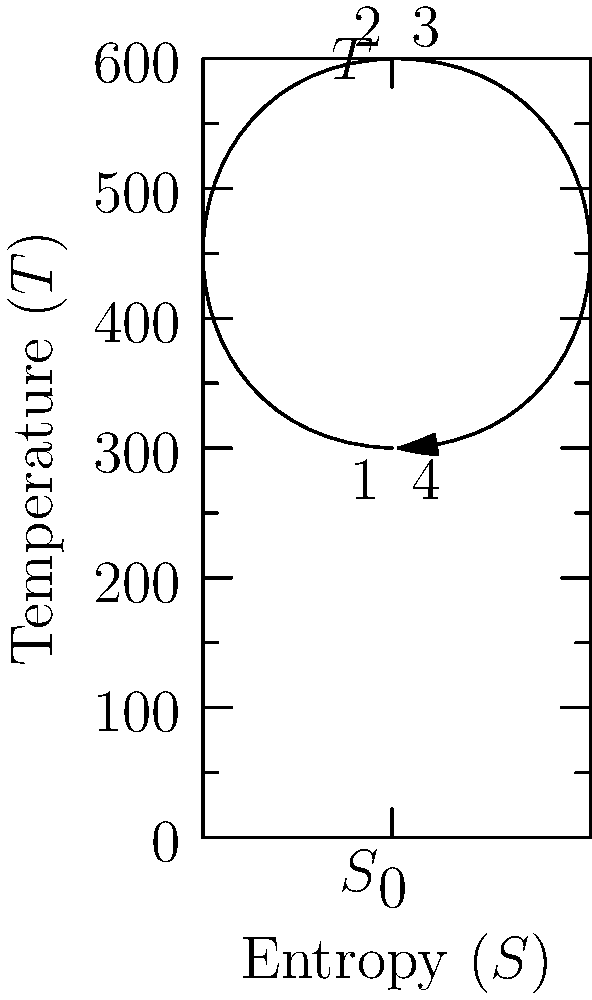In a heat engine cycle inspired by Kanika Tekriwal's innovative approach to problem-solving, the working fluid undergoes the process shown in the T-S diagram. If the heat input occurs at a constant temperature of 600 K and the heat rejection occurs at a constant temperature of 300 K, calculate the thermal efficiency of this cycle. To calculate the thermal efficiency of this heat engine cycle, we'll follow these steps:

1) The thermal efficiency ($\eta$) of a heat engine is defined as:

   $$\eta = \frac{W_{net}}{Q_{in}} = 1 - \frac{Q_{out}}{Q_{in}}$$

2) For a cycle operating between two constant temperatures, we can use the Carnot efficiency formula:

   $$\eta = 1 - \frac{T_{cold}}{T_{hot}}$$

3) From the diagram, we can identify:
   $T_{hot} = 600$ K (temperature of heat input)
   $T_{cold} = 300$ K (temperature of heat rejection)

4) Substituting these values into the Carnot efficiency formula:

   $$\eta = 1 - \frac{300}{600} = 1 - \frac{1}{2} = 0.5$$

5) Convert to percentage:

   $$\eta = 0.5 \times 100\% = 50\%$$

This result shows that the cycle converts 50% of the input heat into useful work, demonstrating an impressive efficiency that would certainly be appreciated in innovative engineering applications.
Answer: 50% 